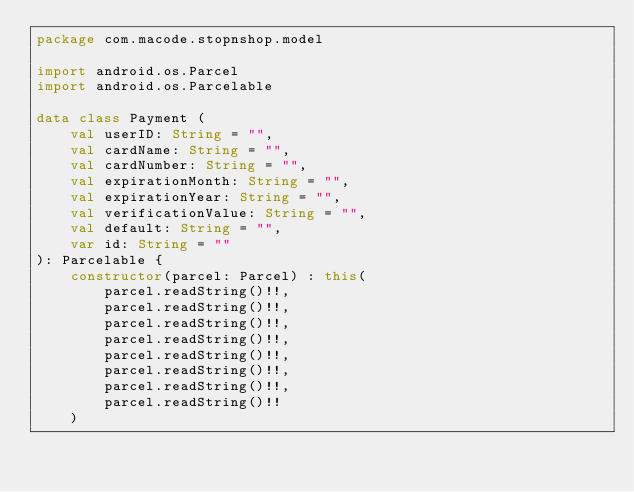Convert code to text. <code><loc_0><loc_0><loc_500><loc_500><_Kotlin_>package com.macode.stopnshop.model

import android.os.Parcel
import android.os.Parcelable

data class Payment (
    val userID: String = "",
    val cardName: String = "",
    val cardNumber: String = "",
    val expirationMonth: String = "",
    val expirationYear: String = "",
    val verificationValue: String = "",
    val default: String = "",
    var id: String = ""
): Parcelable {
    constructor(parcel: Parcel) : this(
        parcel.readString()!!,
        parcel.readString()!!,
        parcel.readString()!!,
        parcel.readString()!!,
        parcel.readString()!!,
        parcel.readString()!!,
        parcel.readString()!!,
        parcel.readString()!!
    )
</code> 